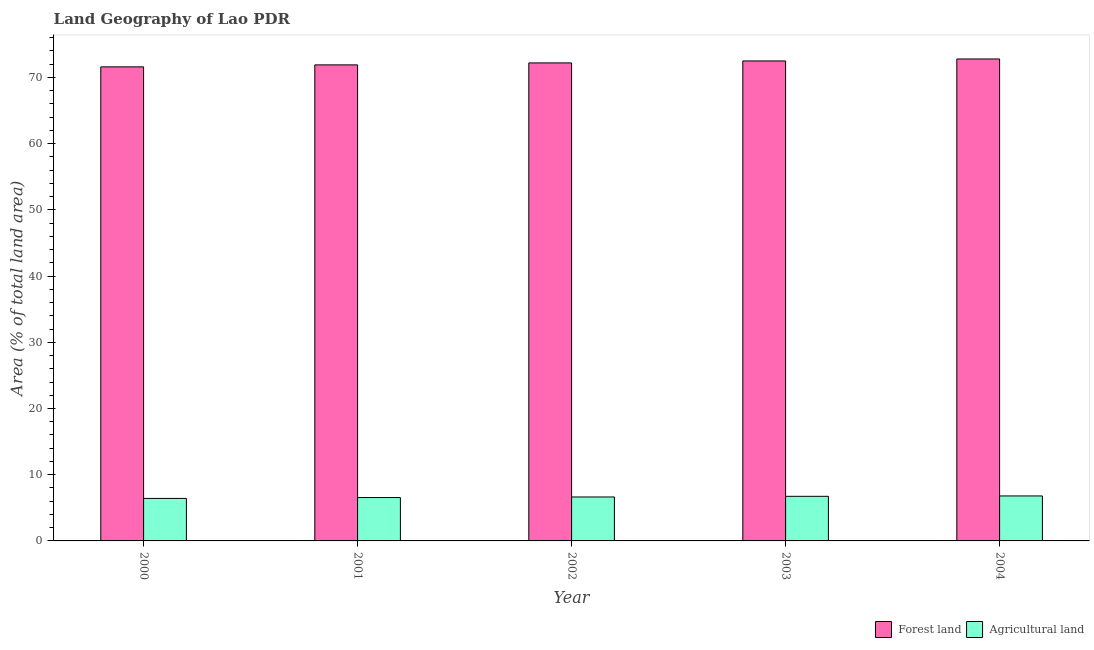How many bars are there on the 2nd tick from the left?
Make the answer very short. 2. How many bars are there on the 3rd tick from the right?
Provide a succinct answer. 2. What is the label of the 5th group of bars from the left?
Offer a terse response. 2004. In how many cases, is the number of bars for a given year not equal to the number of legend labels?
Give a very brief answer. 0. What is the percentage of land area under agriculture in 2002?
Offer a terse response. 6.64. Across all years, what is the maximum percentage of land area under forests?
Offer a very short reply. 72.79. Across all years, what is the minimum percentage of land area under agriculture?
Provide a short and direct response. 6.42. In which year was the percentage of land area under agriculture maximum?
Offer a very short reply. 2004. What is the total percentage of land area under forests in the graph?
Offer a very short reply. 360.99. What is the difference between the percentage of land area under agriculture in 2000 and that in 2001?
Keep it short and to the point. -0.13. What is the difference between the percentage of land area under agriculture in 2001 and the percentage of land area under forests in 2002?
Your response must be concise. -0.09. What is the average percentage of land area under forests per year?
Ensure brevity in your answer.  72.2. In the year 2003, what is the difference between the percentage of land area under forests and percentage of land area under agriculture?
Your answer should be very brief. 0. In how many years, is the percentage of land area under forests greater than 20 %?
Offer a terse response. 5. What is the ratio of the percentage of land area under forests in 2000 to that in 2002?
Your answer should be compact. 0.99. What is the difference between the highest and the second highest percentage of land area under agriculture?
Give a very brief answer. 0.06. What is the difference between the highest and the lowest percentage of land area under agriculture?
Offer a terse response. 0.37. In how many years, is the percentage of land area under forests greater than the average percentage of land area under forests taken over all years?
Provide a short and direct response. 3. Is the sum of the percentage of land area under forests in 2001 and 2002 greater than the maximum percentage of land area under agriculture across all years?
Your answer should be very brief. Yes. What does the 1st bar from the left in 2002 represents?
Your answer should be very brief. Forest land. What does the 2nd bar from the right in 2000 represents?
Your response must be concise. Forest land. Are all the bars in the graph horizontal?
Your answer should be very brief. No. How many years are there in the graph?
Your response must be concise. 5. What is the difference between two consecutive major ticks on the Y-axis?
Your answer should be very brief. 10. What is the title of the graph?
Ensure brevity in your answer.  Land Geography of Lao PDR. What is the label or title of the Y-axis?
Give a very brief answer. Area (% of total land area). What is the Area (% of total land area) in Forest land in 2000?
Offer a terse response. 71.6. What is the Area (% of total land area) of Agricultural land in 2000?
Offer a very short reply. 6.42. What is the Area (% of total land area) of Forest land in 2001?
Ensure brevity in your answer.  71.9. What is the Area (% of total land area) in Agricultural land in 2001?
Provide a short and direct response. 6.55. What is the Area (% of total land area) of Forest land in 2002?
Give a very brief answer. 72.2. What is the Area (% of total land area) of Agricultural land in 2002?
Your answer should be very brief. 6.64. What is the Area (% of total land area) of Forest land in 2003?
Your answer should be very brief. 72.5. What is the Area (% of total land area) in Agricultural land in 2003?
Offer a very short reply. 6.74. What is the Area (% of total land area) of Forest land in 2004?
Your answer should be very brief. 72.79. What is the Area (% of total land area) of Agricultural land in 2004?
Offer a very short reply. 6.79. Across all years, what is the maximum Area (% of total land area) in Forest land?
Your answer should be compact. 72.79. Across all years, what is the maximum Area (% of total land area) of Agricultural land?
Your response must be concise. 6.79. Across all years, what is the minimum Area (% of total land area) of Forest land?
Ensure brevity in your answer.  71.6. Across all years, what is the minimum Area (% of total land area) in Agricultural land?
Your answer should be compact. 6.42. What is the total Area (% of total land area) in Forest land in the graph?
Offer a very short reply. 360.99. What is the total Area (% of total land area) in Agricultural land in the graph?
Your answer should be compact. 33.14. What is the difference between the Area (% of total land area) in Forest land in 2000 and that in 2001?
Your answer should be compact. -0.3. What is the difference between the Area (% of total land area) in Agricultural land in 2000 and that in 2001?
Give a very brief answer. -0.13. What is the difference between the Area (% of total land area) in Forest land in 2000 and that in 2002?
Offer a very short reply. -0.6. What is the difference between the Area (% of total land area) in Agricultural land in 2000 and that in 2002?
Your answer should be compact. -0.22. What is the difference between the Area (% of total land area) of Forest land in 2000 and that in 2003?
Your response must be concise. -0.89. What is the difference between the Area (% of total land area) in Agricultural land in 2000 and that in 2003?
Ensure brevity in your answer.  -0.32. What is the difference between the Area (% of total land area) in Forest land in 2000 and that in 2004?
Your response must be concise. -1.19. What is the difference between the Area (% of total land area) in Agricultural land in 2000 and that in 2004?
Your answer should be very brief. -0.37. What is the difference between the Area (% of total land area) in Forest land in 2001 and that in 2002?
Your answer should be compact. -0.3. What is the difference between the Area (% of total land area) of Agricultural land in 2001 and that in 2002?
Ensure brevity in your answer.  -0.09. What is the difference between the Area (% of total land area) in Forest land in 2001 and that in 2003?
Keep it short and to the point. -0.6. What is the difference between the Area (% of total land area) of Agricultural land in 2001 and that in 2003?
Your response must be concise. -0.19. What is the difference between the Area (% of total land area) of Forest land in 2001 and that in 2004?
Keep it short and to the point. -0.89. What is the difference between the Area (% of total land area) in Agricultural land in 2001 and that in 2004?
Your answer should be very brief. -0.24. What is the difference between the Area (% of total land area) in Forest land in 2002 and that in 2003?
Keep it short and to the point. -0.3. What is the difference between the Area (% of total land area) of Agricultural land in 2002 and that in 2003?
Ensure brevity in your answer.  -0.1. What is the difference between the Area (% of total land area) of Forest land in 2002 and that in 2004?
Make the answer very short. -0.6. What is the difference between the Area (% of total land area) of Agricultural land in 2002 and that in 2004?
Offer a terse response. -0.16. What is the difference between the Area (% of total land area) of Forest land in 2003 and that in 2004?
Offer a very short reply. -0.3. What is the difference between the Area (% of total land area) in Agricultural land in 2003 and that in 2004?
Make the answer very short. -0.06. What is the difference between the Area (% of total land area) of Forest land in 2000 and the Area (% of total land area) of Agricultural land in 2001?
Your answer should be very brief. 65.05. What is the difference between the Area (% of total land area) in Forest land in 2000 and the Area (% of total land area) in Agricultural land in 2002?
Keep it short and to the point. 64.97. What is the difference between the Area (% of total land area) of Forest land in 2000 and the Area (% of total land area) of Agricultural land in 2003?
Ensure brevity in your answer.  64.87. What is the difference between the Area (% of total land area) in Forest land in 2000 and the Area (% of total land area) in Agricultural land in 2004?
Make the answer very short. 64.81. What is the difference between the Area (% of total land area) in Forest land in 2001 and the Area (% of total land area) in Agricultural land in 2002?
Your response must be concise. 65.26. What is the difference between the Area (% of total land area) in Forest land in 2001 and the Area (% of total land area) in Agricultural land in 2003?
Ensure brevity in your answer.  65.16. What is the difference between the Area (% of total land area) of Forest land in 2001 and the Area (% of total land area) of Agricultural land in 2004?
Your answer should be very brief. 65.11. What is the difference between the Area (% of total land area) of Forest land in 2002 and the Area (% of total land area) of Agricultural land in 2003?
Make the answer very short. 65.46. What is the difference between the Area (% of total land area) in Forest land in 2002 and the Area (% of total land area) in Agricultural land in 2004?
Your response must be concise. 65.41. What is the difference between the Area (% of total land area) in Forest land in 2003 and the Area (% of total land area) in Agricultural land in 2004?
Provide a short and direct response. 65.7. What is the average Area (% of total land area) in Forest land per year?
Make the answer very short. 72.2. What is the average Area (% of total land area) of Agricultural land per year?
Provide a succinct answer. 6.63. In the year 2000, what is the difference between the Area (% of total land area) of Forest land and Area (% of total land area) of Agricultural land?
Your answer should be compact. 65.18. In the year 2001, what is the difference between the Area (% of total land area) in Forest land and Area (% of total land area) in Agricultural land?
Offer a very short reply. 65.35. In the year 2002, what is the difference between the Area (% of total land area) in Forest land and Area (% of total land area) in Agricultural land?
Your answer should be very brief. 65.56. In the year 2003, what is the difference between the Area (% of total land area) of Forest land and Area (% of total land area) of Agricultural land?
Keep it short and to the point. 65.76. In the year 2004, what is the difference between the Area (% of total land area) in Forest land and Area (% of total land area) in Agricultural land?
Ensure brevity in your answer.  66. What is the ratio of the Area (% of total land area) of Forest land in 2000 to that in 2001?
Ensure brevity in your answer.  1. What is the ratio of the Area (% of total land area) in Agricultural land in 2000 to that in 2001?
Provide a short and direct response. 0.98. What is the ratio of the Area (% of total land area) of Agricultural land in 2000 to that in 2002?
Offer a terse response. 0.97. What is the ratio of the Area (% of total land area) of Agricultural land in 2000 to that in 2003?
Provide a short and direct response. 0.95. What is the ratio of the Area (% of total land area) in Forest land in 2000 to that in 2004?
Provide a succinct answer. 0.98. What is the ratio of the Area (% of total land area) in Agricultural land in 2000 to that in 2004?
Provide a succinct answer. 0.95. What is the ratio of the Area (% of total land area) of Agricultural land in 2001 to that in 2002?
Ensure brevity in your answer.  0.99. What is the ratio of the Area (% of total land area) of Forest land in 2001 to that in 2003?
Give a very brief answer. 0.99. What is the ratio of the Area (% of total land area) of Agricultural land in 2001 to that in 2003?
Offer a very short reply. 0.97. What is the ratio of the Area (% of total land area) in Agricultural land in 2001 to that in 2004?
Give a very brief answer. 0.96. What is the ratio of the Area (% of total land area) in Forest land in 2002 to that in 2003?
Provide a succinct answer. 1. What is the ratio of the Area (% of total land area) in Agricultural land in 2002 to that in 2003?
Ensure brevity in your answer.  0.99. What is the ratio of the Area (% of total land area) of Forest land in 2002 to that in 2004?
Offer a very short reply. 0.99. What is the ratio of the Area (% of total land area) in Agricultural land in 2002 to that in 2004?
Give a very brief answer. 0.98. What is the difference between the highest and the second highest Area (% of total land area) in Forest land?
Give a very brief answer. 0.3. What is the difference between the highest and the second highest Area (% of total land area) of Agricultural land?
Make the answer very short. 0.06. What is the difference between the highest and the lowest Area (% of total land area) of Forest land?
Your response must be concise. 1.19. What is the difference between the highest and the lowest Area (% of total land area) of Agricultural land?
Ensure brevity in your answer.  0.37. 